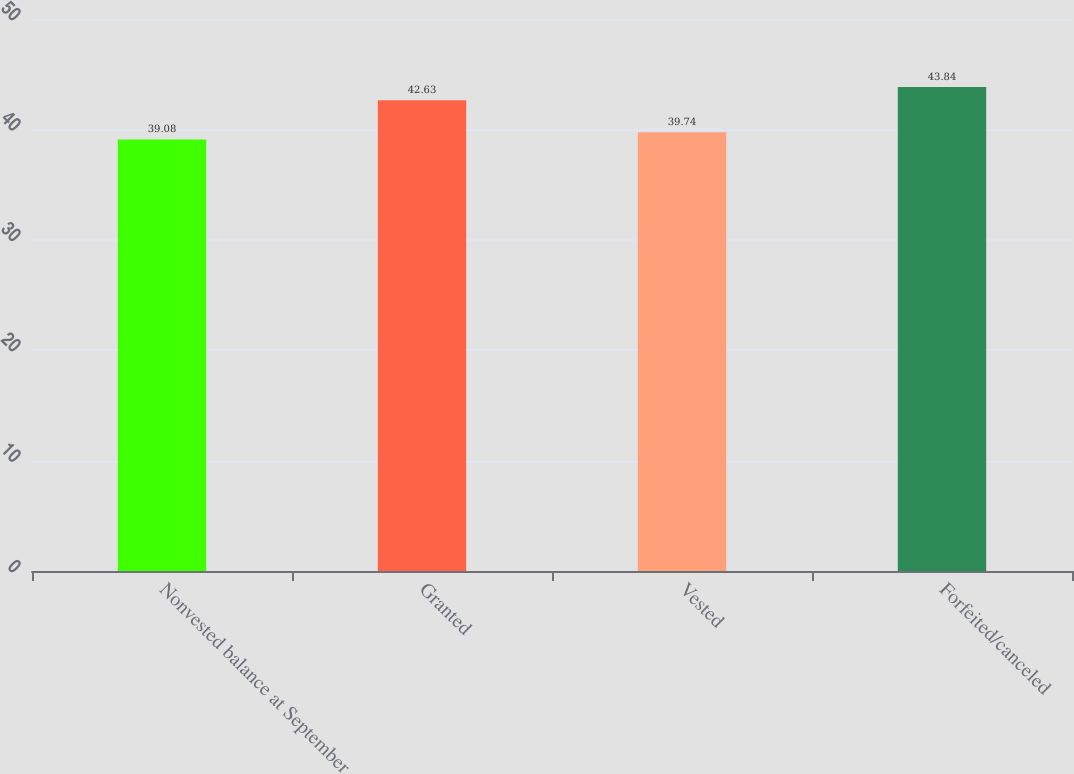<chart> <loc_0><loc_0><loc_500><loc_500><bar_chart><fcel>Nonvested balance at September<fcel>Granted<fcel>Vested<fcel>Forfeited/canceled<nl><fcel>39.08<fcel>42.63<fcel>39.74<fcel>43.84<nl></chart> 